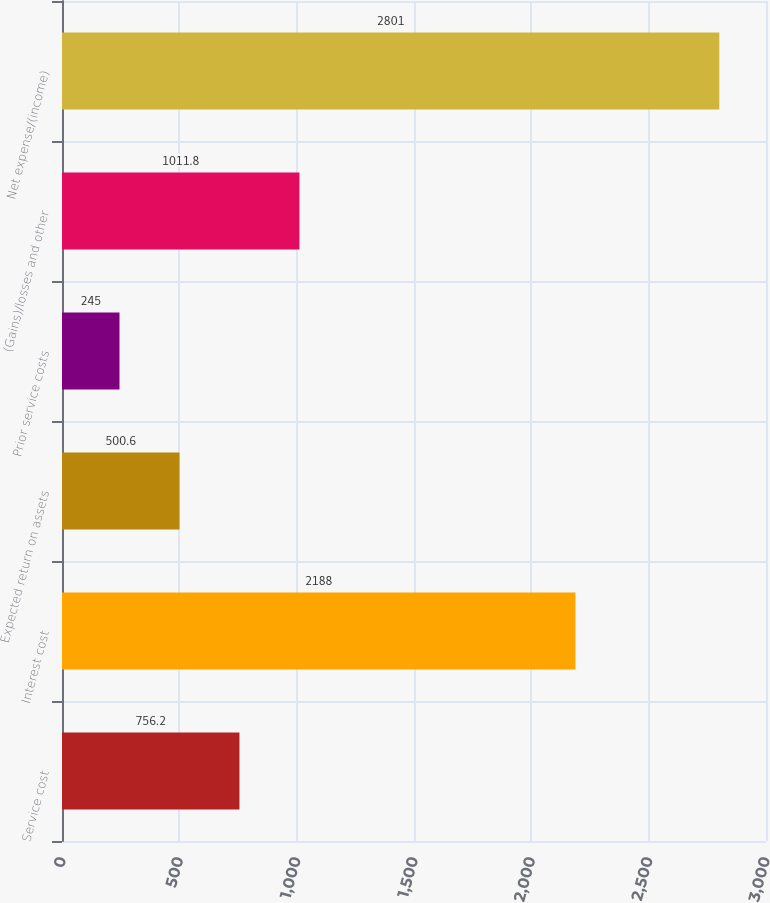Convert chart. <chart><loc_0><loc_0><loc_500><loc_500><bar_chart><fcel>Service cost<fcel>Interest cost<fcel>Expected return on assets<fcel>Prior service costs<fcel>(Gains)/losses and other<fcel>Net expense/(income)<nl><fcel>756.2<fcel>2188<fcel>500.6<fcel>245<fcel>1011.8<fcel>2801<nl></chart> 